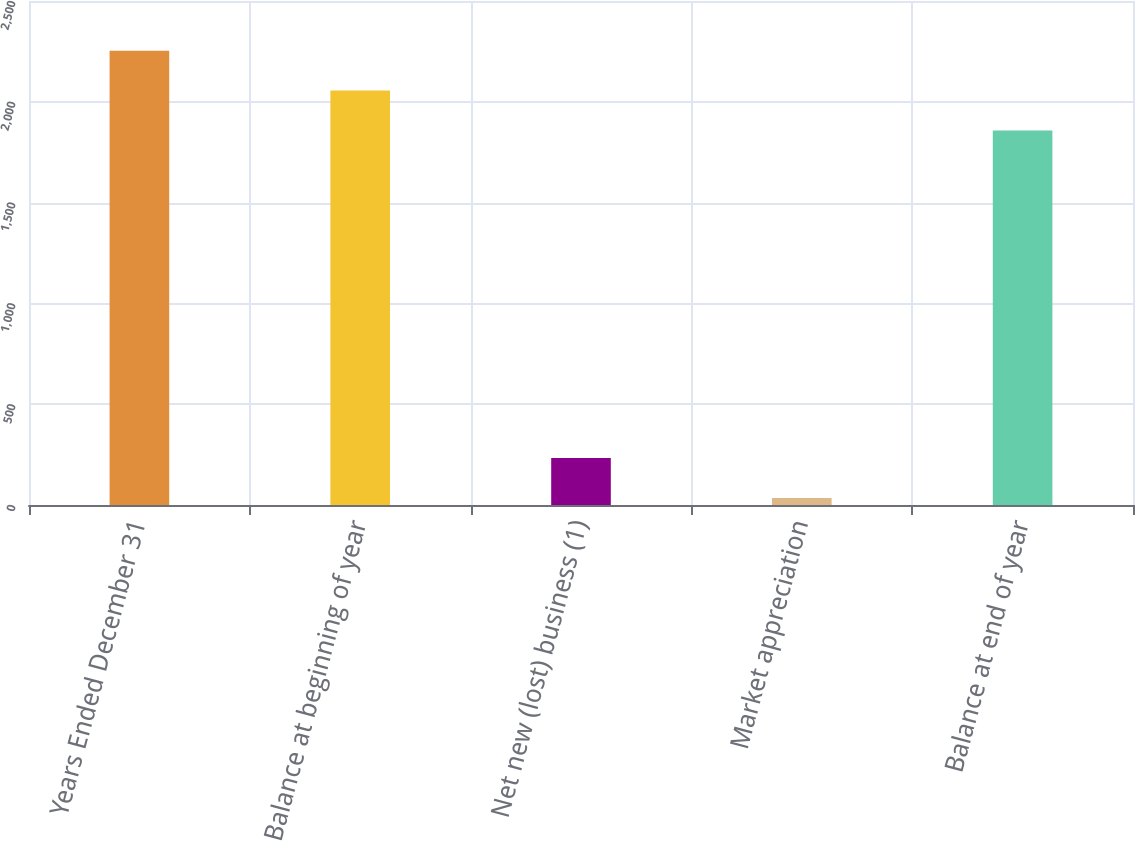<chart> <loc_0><loc_0><loc_500><loc_500><bar_chart><fcel>Years Ended December 31<fcel>Balance at beginning of year<fcel>Net new (lost) business (1)<fcel>Market appreciation<fcel>Balance at end of year<nl><fcel>2253.2<fcel>2055.6<fcel>232.6<fcel>35<fcel>1858<nl></chart> 